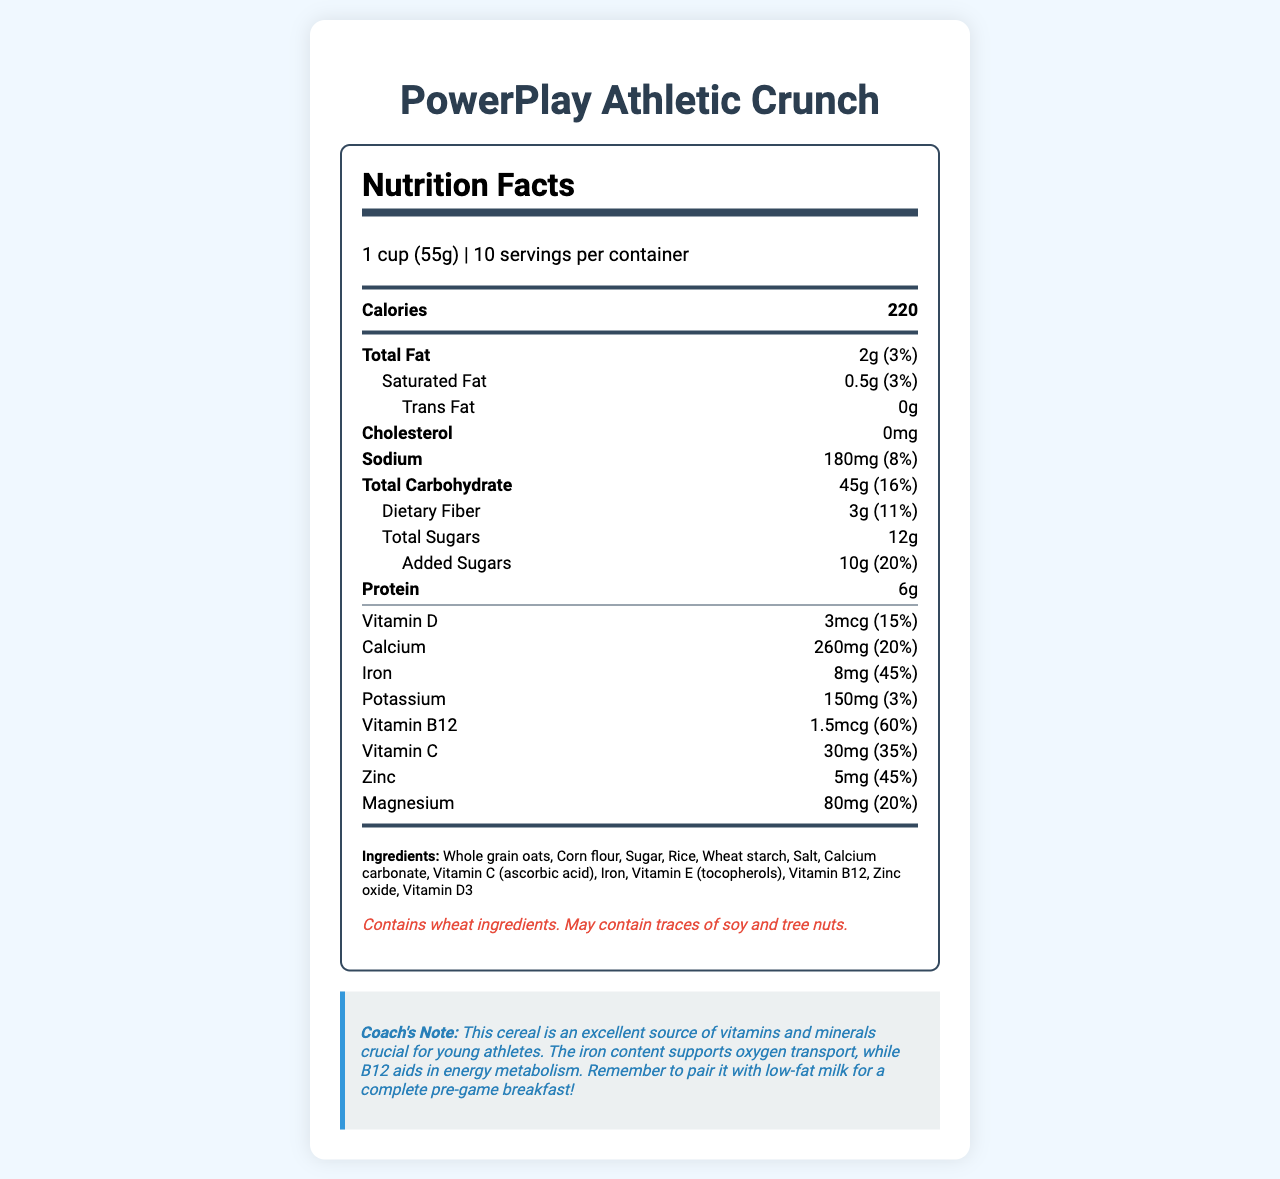what is the serving size? The serving size is listed as "1 cup (55g)".
Answer: 1 cup (55g) how many servings are there per container? It is mentioned that there are 10 servings per container.
Answer: 10 what is the total amount of fat in one serving? The "Total Fat" section specifies that there is 2g of fat per serving.
Answer: 2g how many calories are in one serving? The document indicates there are 220 calories per serving.
Answer: 220 what is the cholesterol content in this cereal? The "Cholesterol" section states there is 0mg of cholesterol.
Answer: 0mg what is the percentage of daily value for iron? The document mentions that the iron content is 8mg, which is 45% of the daily value.
Answer: 45% what vitamins and minerals are particularly high in this cereal? Vitamins and minerals with high percentages include Vitamin B12 (60%), Iron (45%), Vitamin C (35%), and Calcium (20%).
Answer: Vitamin B12, Iron, Vitamin C, Calcium What ingredient is listed first in the ingredients section? Ingredients are listed in order of predominance, and Whole Grain Oats are mentioned first.
Answer: Whole grain oats What is the main source of sugars in the cereal? The total sugars value is 12g, with added sugars contributing 10g, indicating that added sugars are the main source.
Answer: Added Sugars does this product contain any allergens? The allergen information indicates that it contains wheat ingredients and may contain traces of soy and tree nuts.
Answer: Yes Which of the following is NOT an ingredient in PowerPlay Athletic Crunch? 1. Corn Flour 2. Soy 3. Rice 4. Whole Grain Oats Soy is listed as a potential allergen but not as an ingredient.
Answer: 2. Soy How much dietary fiber is in one serving? A. 1g B. 3g C. 5g The nutrition label lists dietary fiber as 3g per serving.
Answer: B. 3g overall, does this cereal provide more calcium or potassium? The percentage of daily value for calcium is 20%, while potassium is only 3%, indicating that the cereal provides more calcium.
Answer: Calcium How would you summarize the nutrition profile of PowerPlay Athletic Crunch? The document provides detailed nutrition facts, emphasizing its suitability for young athletes with its high levels of essential vitamins and minerals, moderate calories, and additional coach's note for optimum use.
Answer: PowerPlay Athletic Crunch is a vitamin-fortified cereal designed for young athletes, offering significant amounts of vitamins and minerals including Vitamin B12, Iron, and Vitamin C. It has a moderate calorie count and moderate amounts of protein and fiber. can the exact date of manufacturing be found in the document? The document does not provide any details about the manufacturing date, so this information cannot be determined from the provided visual details.
Answer: Not enough information 